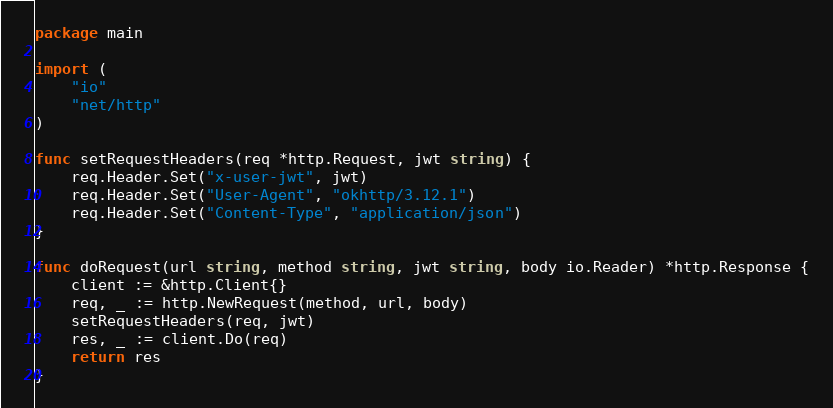Convert code to text. <code><loc_0><loc_0><loc_500><loc_500><_Go_>package main

import (
	"io"
	"net/http"
)

func setRequestHeaders(req *http.Request, jwt string) {
	req.Header.Set("x-user-jwt", jwt)
	req.Header.Set("User-Agent", "okhttp/3.12.1")
	req.Header.Set("Content-Type", "application/json")
}

func doRequest(url string, method string, jwt string, body io.Reader) *http.Response {
	client := &http.Client{}
	req, _ := http.NewRequest(method, url, body)
	setRequestHeaders(req, jwt)
	res, _ := client.Do(req)
	return res
}
</code> 